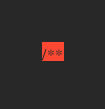<code> <loc_0><loc_0><loc_500><loc_500><_TypeScript_>/**</code> 